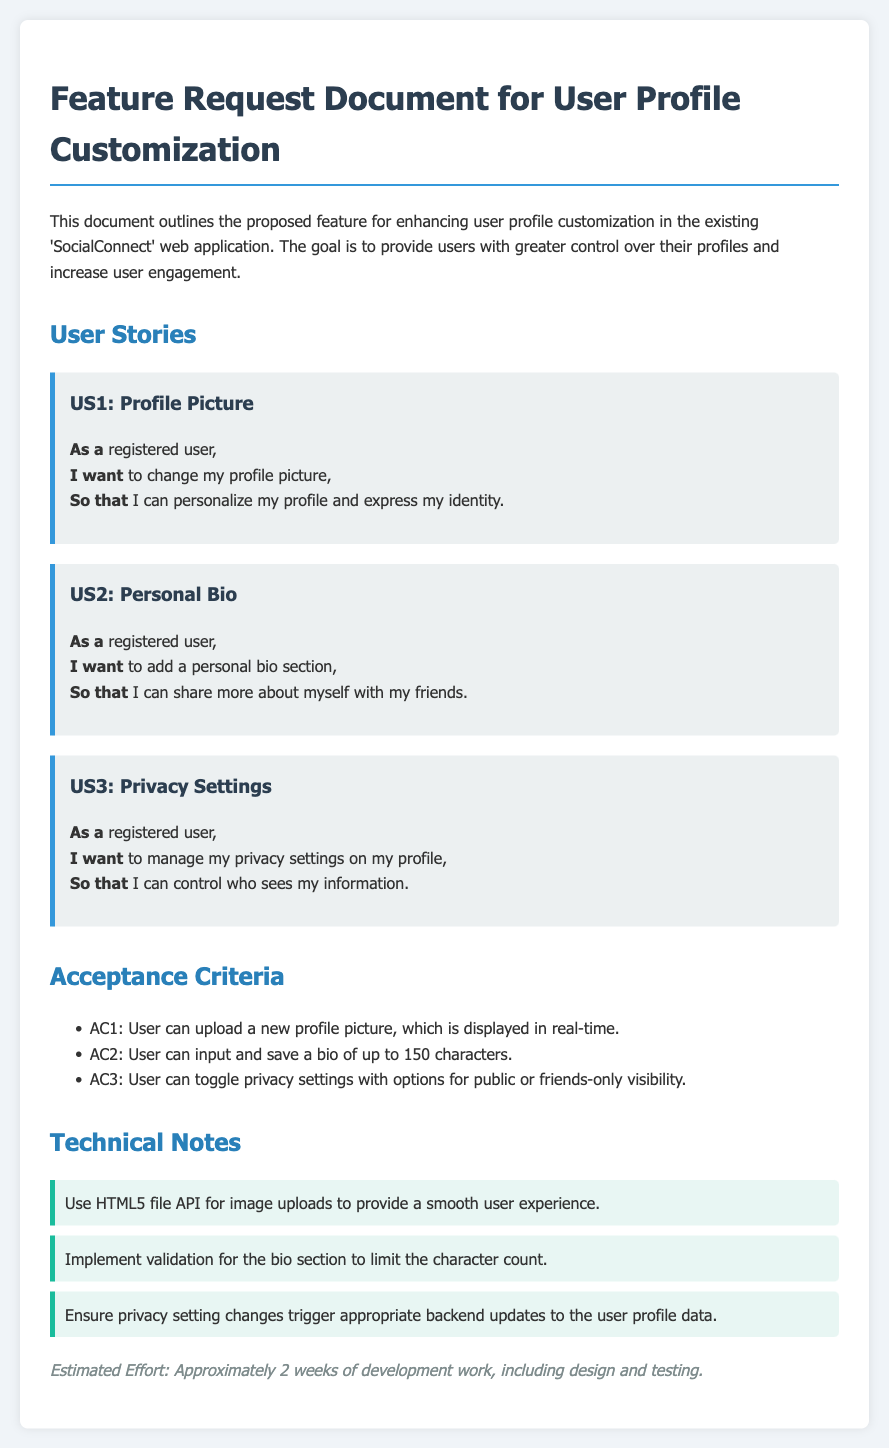What is the feature request about? The feature request outlines the proposed enhancement for user profile customization in the 'SocialConnect' web application.
Answer: User Profile Customization How many user stories are outlined? The document lists three user stories for profile customization.
Answer: 3 What is the maximum character count for the personal bio? The personal bio section has a character limit set by the acceptance criteria.
Answer: 150 characters What can users manage according to US3? US3 details what registered users can manage in their profiles for privacy control.
Answer: Privacy settings What is the estimated development effort? The estimated effort for development work, including design and testing, is stated in the document.
Answer: Approximately 2 weeks What technology is suggested for image uploads? A technical note in the document suggests a technology for handling image uploads efficiently.
Answer: HTML5 file API What options are available for the privacy settings? The acceptance criteria specify what options users have for privacy settings visibility.
Answer: Public or friends-only What section allows users to express their identity? The document describes a user story that focuses on personalization.
Answer: Profile Picture 